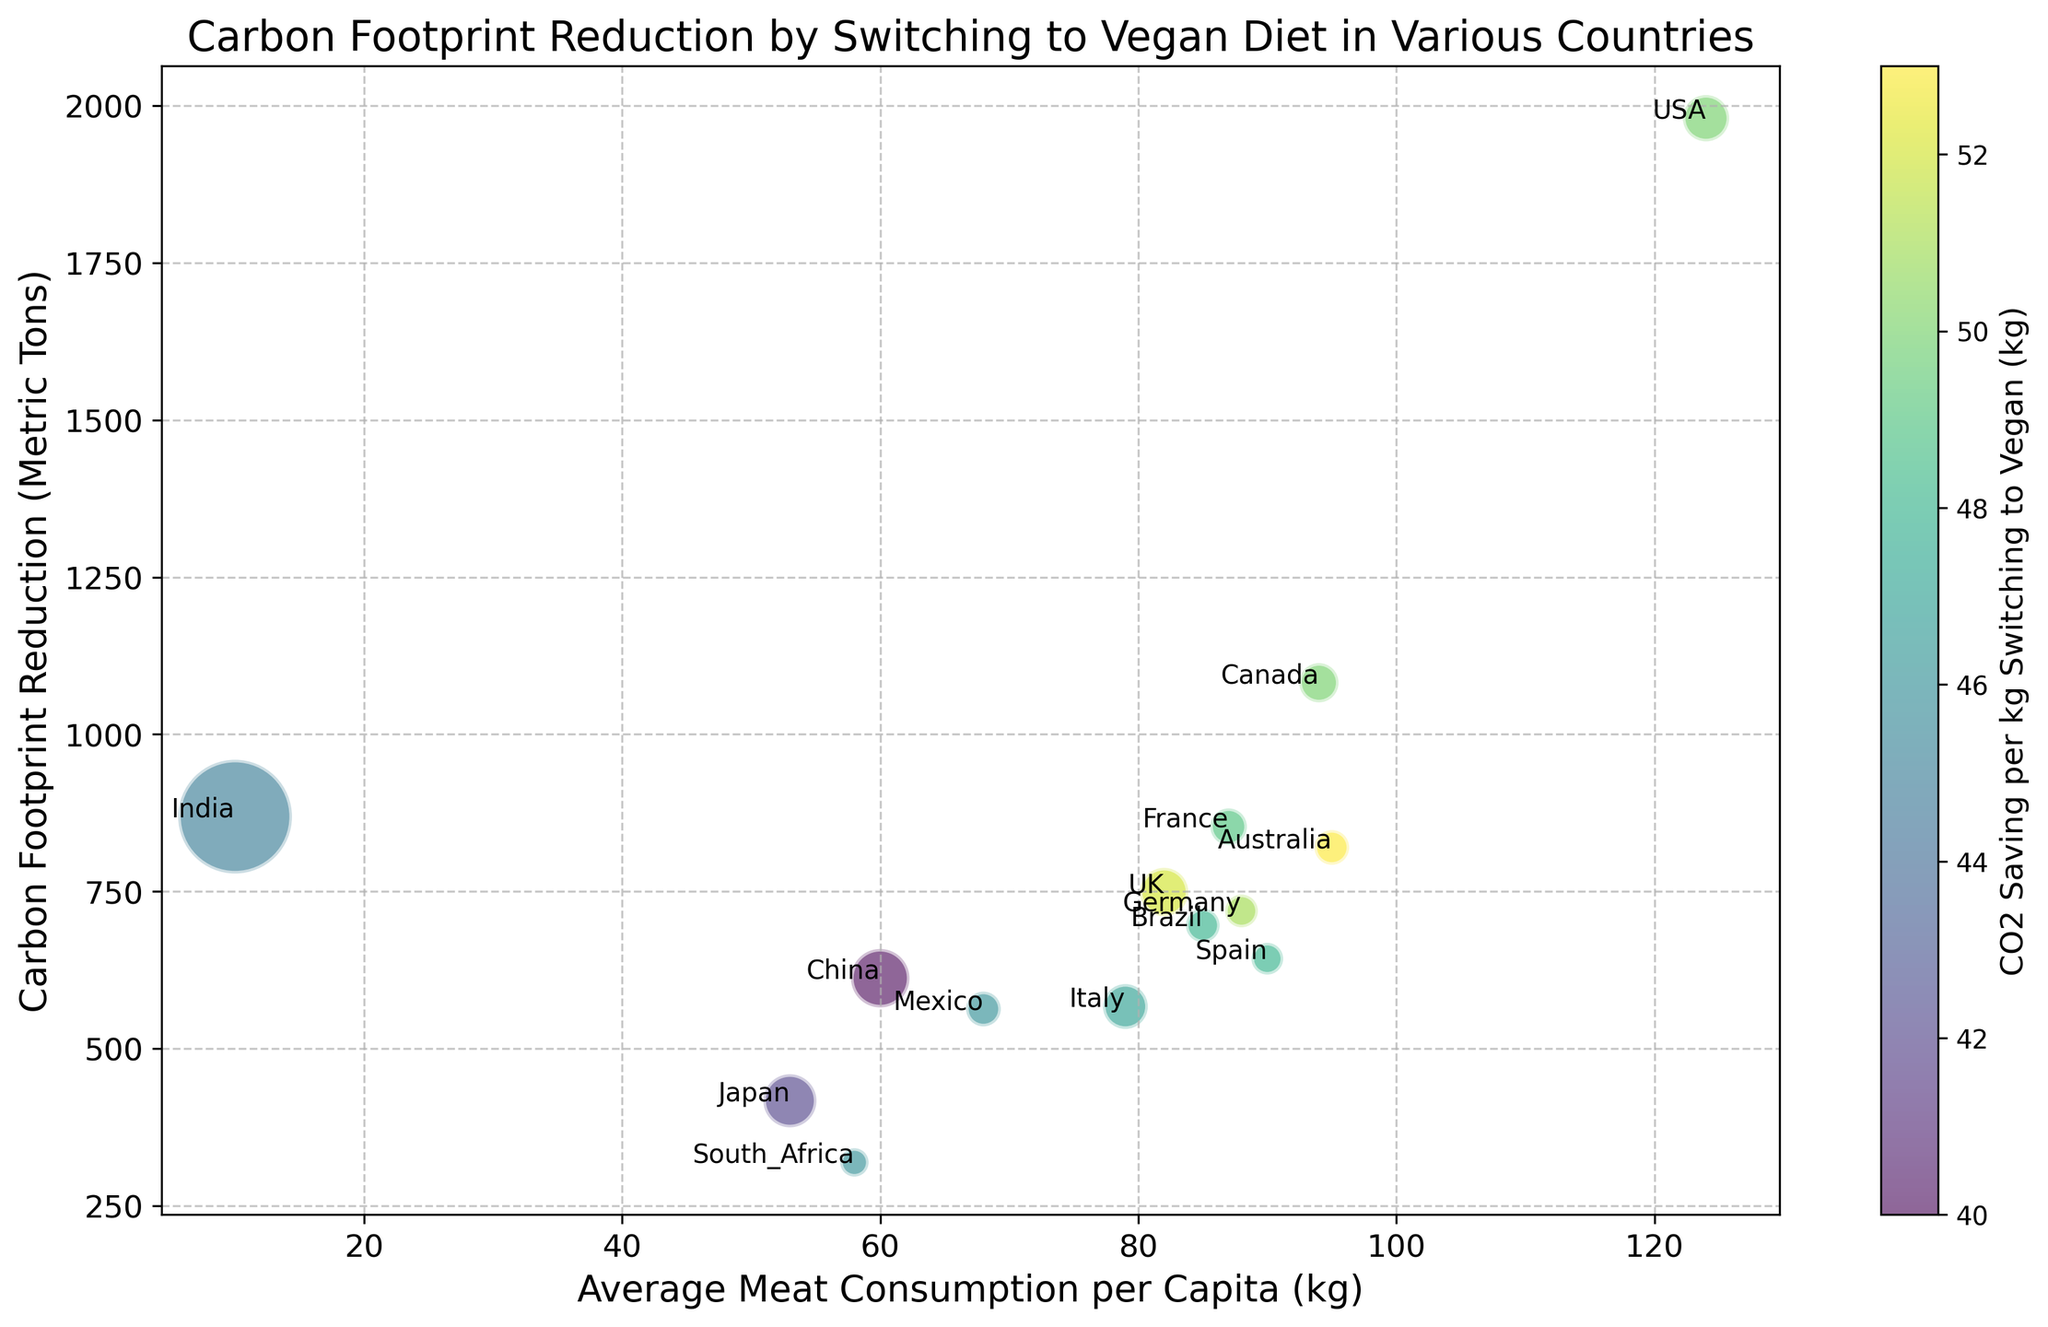Which country has the highest carbon footprint reduction by switching to a vegan diet? By inspecting the vertical positions of the bubbles (the y-axis), the USA has the highest carbon footprint reduction value with 1980 metric tons.
Answer: USA Which country has the lowest CO2 saving per kg by switching to a vegan diet? By looking at the color bar and the colors of the bubbles, China has the lowest CO2 saving per kg, represented by lighter color shades.
Answer: China For the country with the highest percentage of vegans, what is the average meat consumption per capita (kg)? India has the highest percentage of vegans (largest bubble). By examining the x-axis position of India's bubble, the average meat consumption per capita is 10 kg.
Answer: 10 Compare Germany and the UK: Which country has a higher CO2 saving per kg by switching to a vegan diet? By comparing the colors of their respective bubbles, the UK has a darker shade indicating a higher CO2 saving per kg (52 kg) compared to Germany (51 kg).
Answer: UK What is the difference in carbon footprint reduction between Canada and France? From the y-axis positions, Canada's carbon footprint reduction is 1082 metric tons, and France's is 853 metric tons. The difference is 1082 - 853 = 229 metric tons.
Answer: 229 Which country with less than 2% vegans achieves more than 600 metric tons of carbon footprint reduction? By filtering bubbles with smaller sizes representing <2% vegans and looking at their vertical positions, Germany and South Africa need to be inspected. Germany achieves 719 metric tons, while South Africa achieves 319 metric tons. So, Germany achieves more than 600 metric tons.
Answer: Germany How does Japan's average meat consumption per capita compare to Italy's? By examining the x-axis positions, Japan's average meat consumption is 53 kg, whereas Italy's is 79 kg. Thus, Japan's average meat consumption is lower than Italy's.
Answer: Lower Identify the country with a carbon footprint reduction closest to 600 metric tons. The countries closest to 600 metric tons from the y-axis are China (612 metric tons) and Mexico (563 metric tons). Among these, China is closer.
Answer: China 